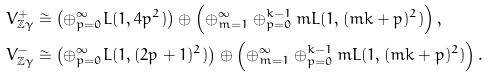<formula> <loc_0><loc_0><loc_500><loc_500>V _ { { \mathbb { Z } } \gamma } ^ { + } & \cong \left ( \oplus _ { p = 0 } ^ { \infty } L ( 1 , 4 p ^ { 2 } ) \right ) \oplus \left ( \oplus _ { m = 1 } ^ { \infty } \oplus _ { p = 0 } ^ { k - 1 } m L ( 1 , ( m k + p ) ^ { 2 } ) \right ) , \\ V _ { { \mathbb { Z } } \gamma } ^ { - } & \cong \left ( \oplus _ { p = 0 } ^ { \infty } L ( 1 , ( 2 p + 1 ) ^ { 2 } ) \right ) \oplus \left ( \oplus _ { m = 1 } ^ { \infty } \oplus _ { p = 0 } ^ { k - 1 } m L ( 1 , ( m k + p ) ^ { 2 } ) \right ) .</formula> 